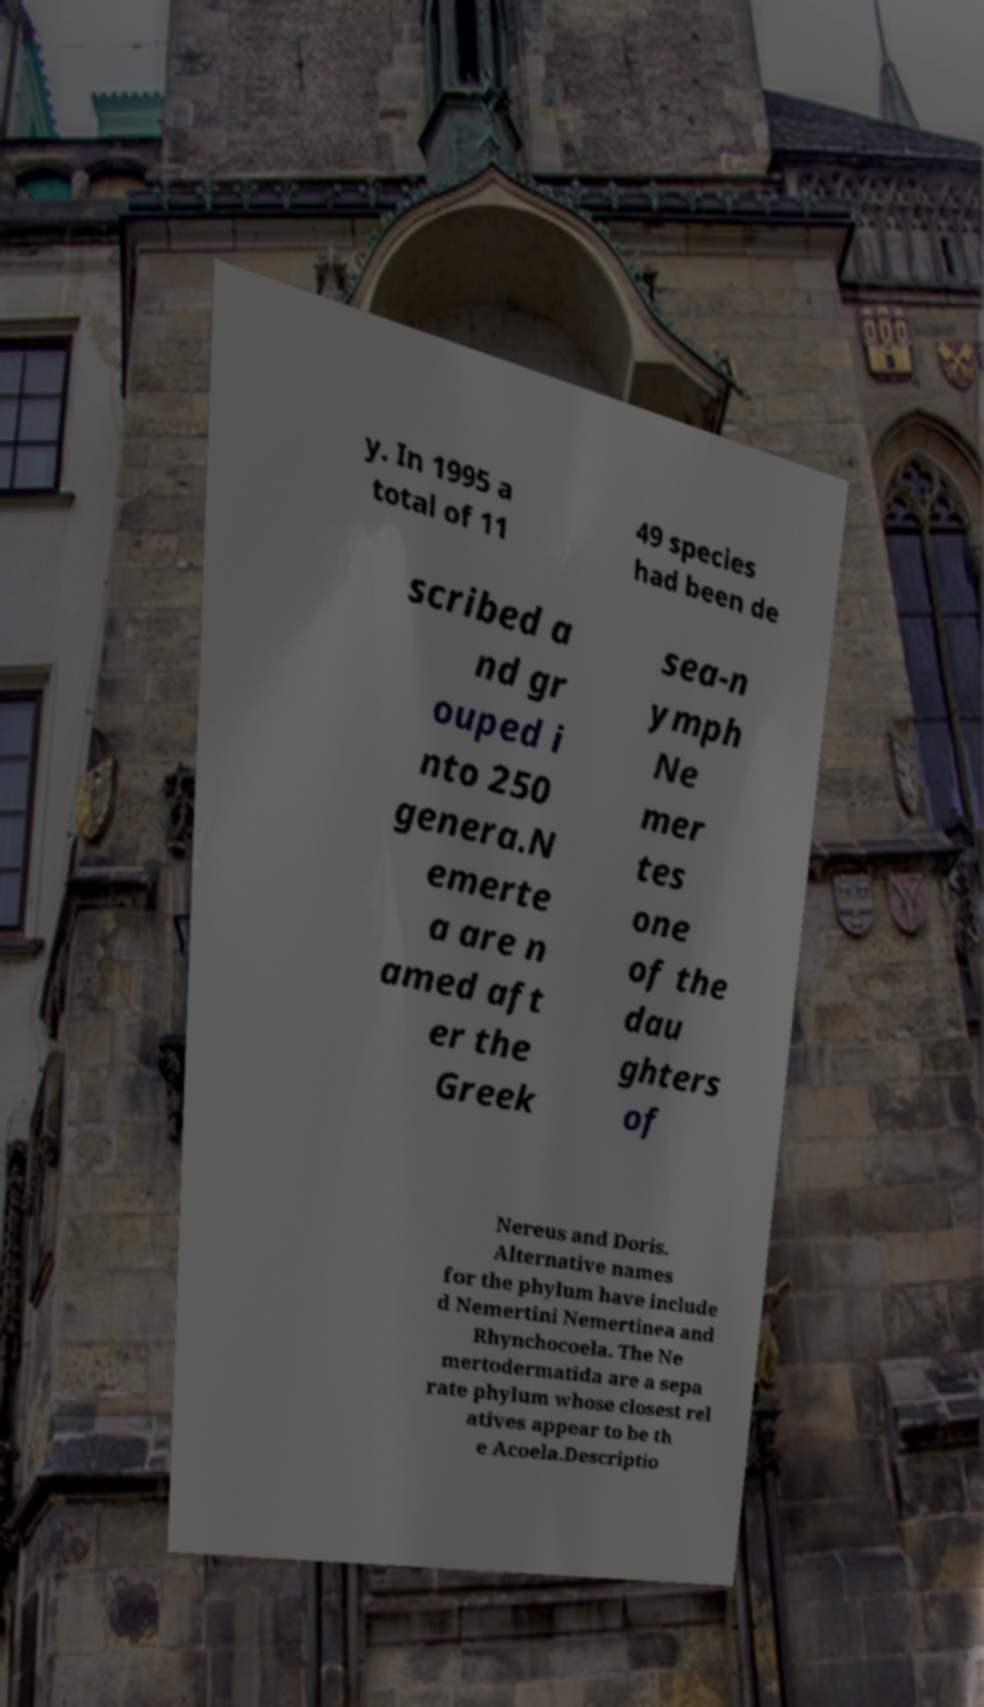Could you extract and type out the text from this image? y. In 1995 a total of 11 49 species had been de scribed a nd gr ouped i nto 250 genera.N emerte a are n amed aft er the Greek sea-n ymph Ne mer tes one of the dau ghters of Nereus and Doris. Alternative names for the phylum have include d Nemertini Nemertinea and Rhynchocoela. The Ne mertodermatida are a sepa rate phylum whose closest rel atives appear to be th e Acoela.Descriptio 